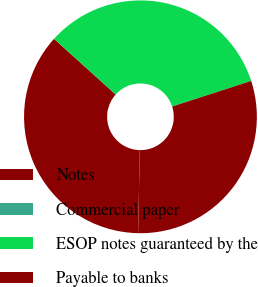<chart> <loc_0><loc_0><loc_500><loc_500><pie_chart><fcel>Notes<fcel>Commercial paper<fcel>ESOP notes guaranteed by the<fcel>Payable to banks<nl><fcel>36.36%<fcel>0.0%<fcel>33.33%<fcel>30.3%<nl></chart> 